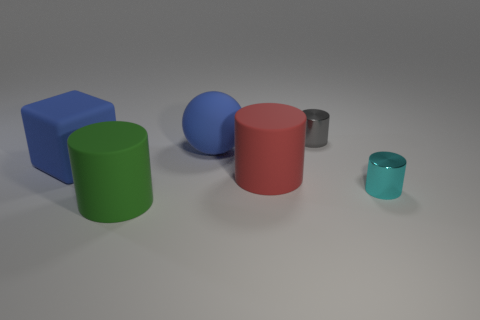What shape is the big rubber thing that is to the right of the large green matte cylinder and in front of the large blue rubber cube?
Your answer should be compact. Cylinder. How many other objects are there of the same color as the sphere?
Offer a very short reply. 1. What number of objects are big matte cylinders behind the large green object or gray metal things?
Keep it short and to the point. 2. Is the color of the sphere the same as the large matte cube left of the rubber sphere?
Provide a succinct answer. Yes. There is a cylinder in front of the metal thing in front of the matte block; what is its size?
Make the answer very short. Large. How many objects are either large red matte cylinders or big matte things that are behind the blue cube?
Your answer should be compact. 2. There is a blue object left of the rubber sphere; is it the same shape as the green matte object?
Provide a succinct answer. No. What number of blue objects are right of the blue matte object that is on the left side of the big thing that is in front of the red object?
Provide a succinct answer. 1. How many things are either big gray shiny cylinders or red objects?
Provide a short and direct response. 1. There is a green object; is its shape the same as the blue rubber object behind the large blue cube?
Offer a terse response. No. 